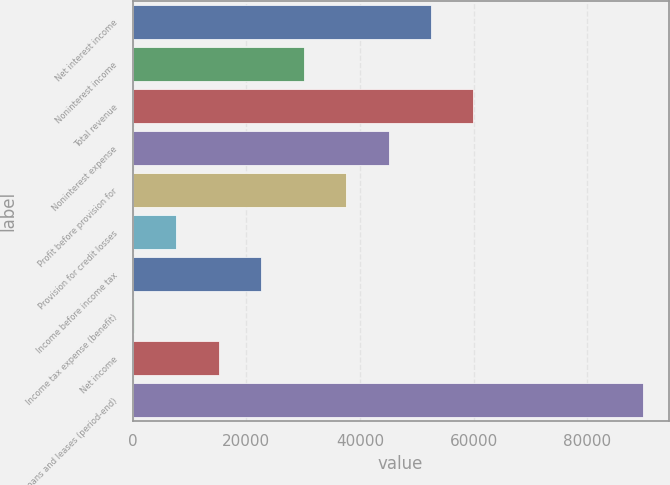Convert chart to OTSL. <chart><loc_0><loc_0><loc_500><loc_500><bar_chart><fcel>Net interest income<fcel>Noninterest income<fcel>Total revenue<fcel>Noninterest expense<fcel>Profit before provision for<fcel>Provision for credit losses<fcel>Income before income tax<fcel>Income tax expense (benefit)<fcel>Net income<fcel>Loans and leases (period-end)<nl><fcel>52484.9<fcel>30096.8<fcel>59947.6<fcel>45022.2<fcel>37559.5<fcel>7708.7<fcel>22634.1<fcel>246<fcel>15171.4<fcel>89798.4<nl></chart> 